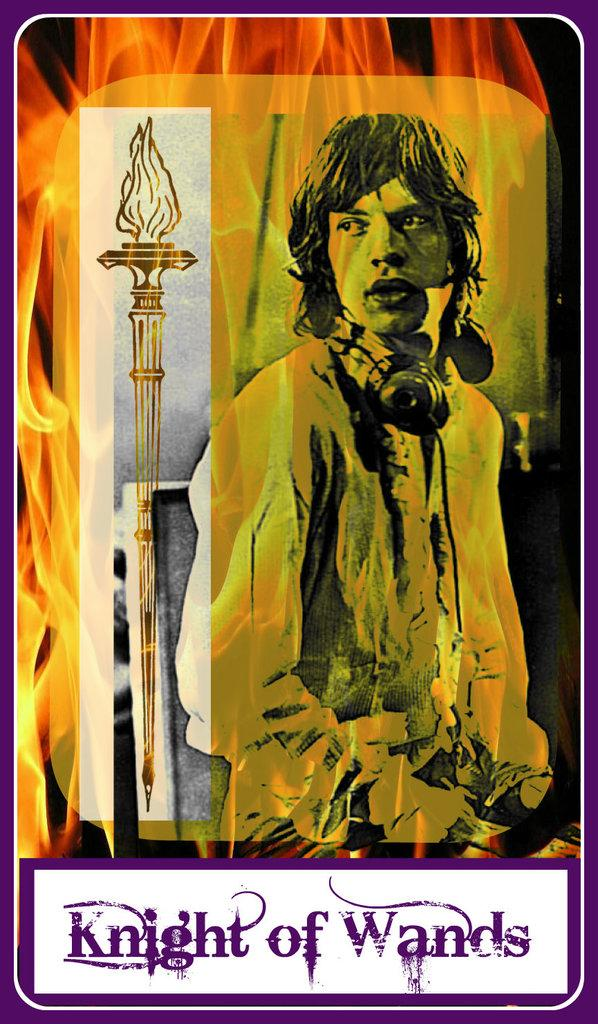Provide a one-sentence caption for the provided image. A man and a staff with Knight of Wands below it. 